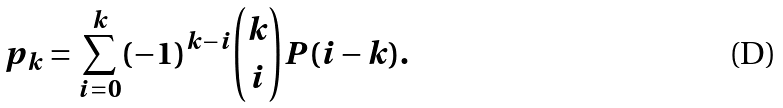<formula> <loc_0><loc_0><loc_500><loc_500>p _ { k } = \sum _ { i = 0 } ^ { k } ( - 1 ) ^ { k - i } { { k } \choose { i } } P ( i - k ) .</formula> 